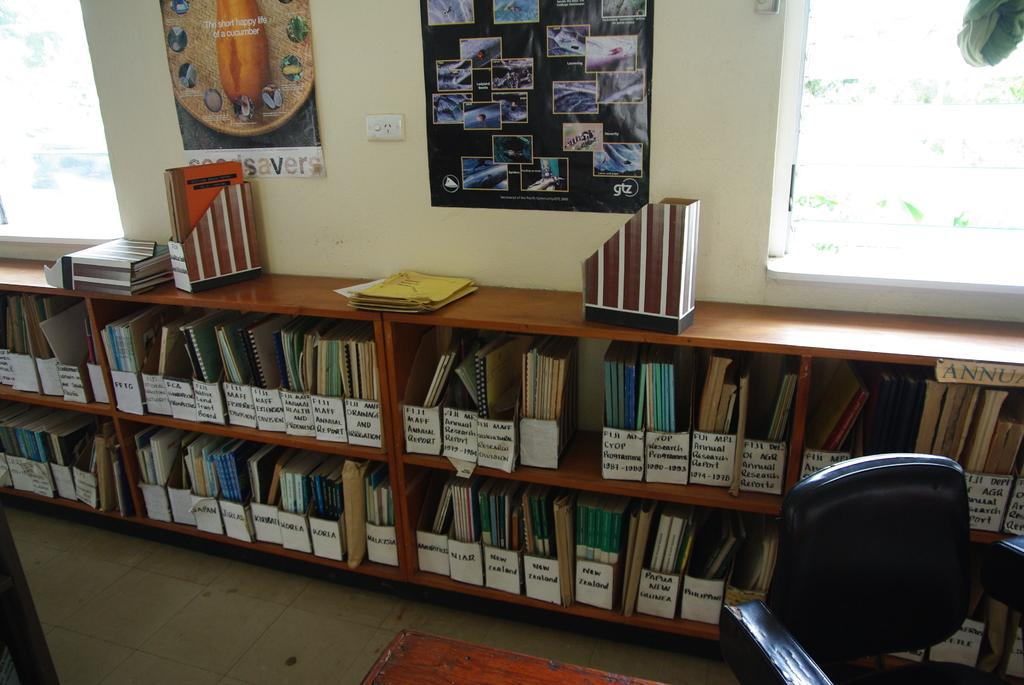<image>
Present a compact description of the photo's key features. Books on New Zealand, Papua New Guinea and the Philippines are stored on the two shelves of a low bookcase. 